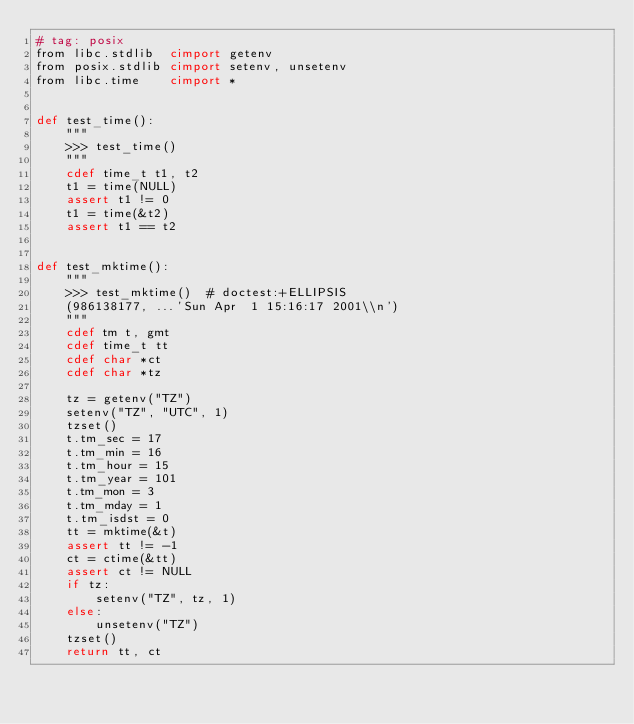<code> <loc_0><loc_0><loc_500><loc_500><_Cython_># tag: posix
from libc.stdlib  cimport getenv
from posix.stdlib cimport setenv, unsetenv
from libc.time    cimport *


def test_time():
    """
    >>> test_time()
    """
    cdef time_t t1, t2
    t1 = time(NULL)
    assert t1 != 0
    t1 = time(&t2)
    assert t1 == t2


def test_mktime():
    """
    >>> test_mktime()  # doctest:+ELLIPSIS
    (986138177, ...'Sun Apr  1 15:16:17 2001\\n')
    """
    cdef tm t, gmt
    cdef time_t tt
    cdef char *ct
    cdef char *tz

    tz = getenv("TZ")
    setenv("TZ", "UTC", 1)
    tzset()
    t.tm_sec = 17
    t.tm_min = 16
    t.tm_hour = 15
    t.tm_year = 101
    t.tm_mon = 3
    t.tm_mday = 1
    t.tm_isdst = 0
    tt = mktime(&t)
    assert tt != -1
    ct = ctime(&tt)
    assert ct != NULL
    if tz:
        setenv("TZ", tz, 1)
    else:
        unsetenv("TZ")
    tzset()
    return tt, ct
</code> 